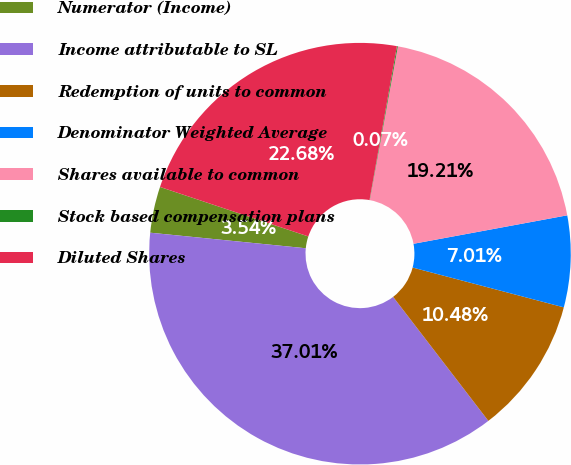Convert chart. <chart><loc_0><loc_0><loc_500><loc_500><pie_chart><fcel>Numerator (Income)<fcel>Income attributable to SL<fcel>Redemption of units to common<fcel>Denominator Weighted Average<fcel>Shares available to common<fcel>Stock based compensation plans<fcel>Diluted Shares<nl><fcel>3.54%<fcel>37.01%<fcel>10.48%<fcel>7.01%<fcel>19.21%<fcel>0.07%<fcel>22.68%<nl></chart> 